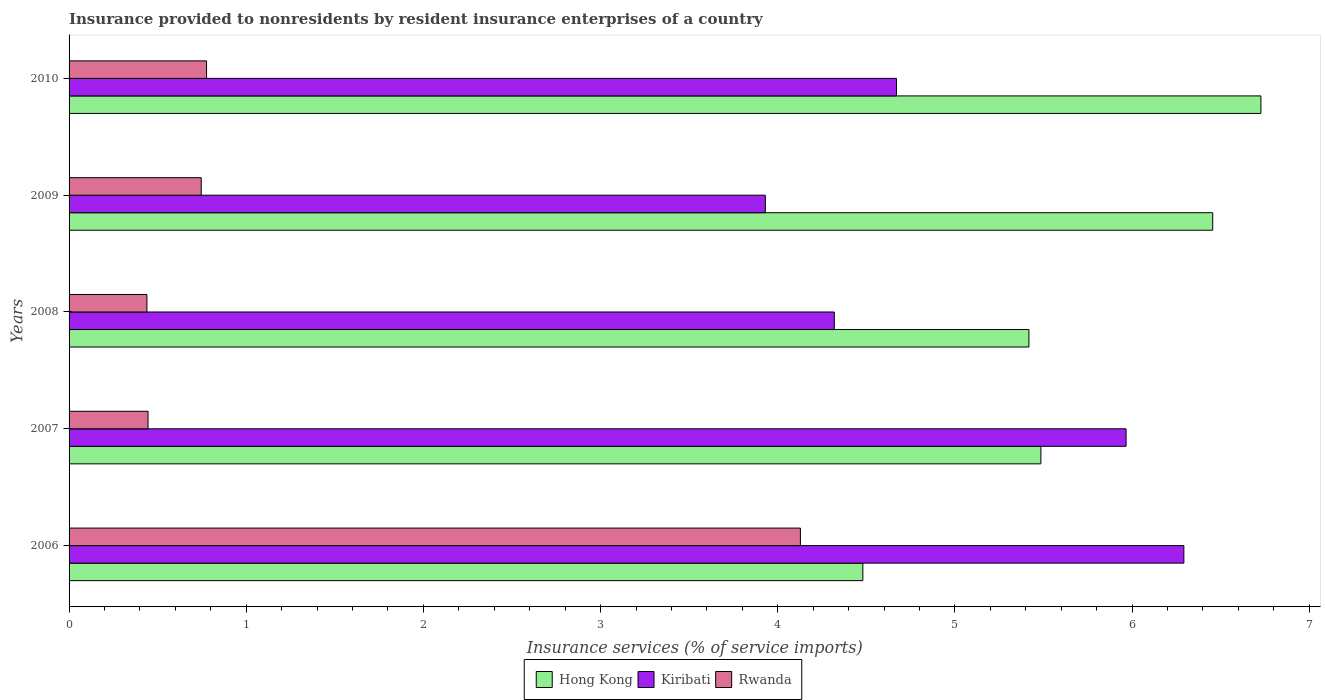How many different coloured bars are there?
Offer a terse response. 3. Are the number of bars per tick equal to the number of legend labels?
Your response must be concise. Yes. How many bars are there on the 5th tick from the bottom?
Keep it short and to the point. 3. What is the insurance provided to nonresidents in Kiribati in 2007?
Ensure brevity in your answer.  5.97. Across all years, what is the maximum insurance provided to nonresidents in Kiribati?
Your answer should be very brief. 6.29. Across all years, what is the minimum insurance provided to nonresidents in Hong Kong?
Keep it short and to the point. 4.48. What is the total insurance provided to nonresidents in Rwanda in the graph?
Make the answer very short. 6.53. What is the difference between the insurance provided to nonresidents in Rwanda in 2006 and that in 2007?
Your answer should be very brief. 3.68. What is the difference between the insurance provided to nonresidents in Kiribati in 2009 and the insurance provided to nonresidents in Rwanda in 2007?
Provide a short and direct response. 3.48. What is the average insurance provided to nonresidents in Kiribati per year?
Your answer should be very brief. 5.04. In the year 2008, what is the difference between the insurance provided to nonresidents in Rwanda and insurance provided to nonresidents in Kiribati?
Make the answer very short. -3.88. In how many years, is the insurance provided to nonresidents in Rwanda greater than 2 %?
Make the answer very short. 1. What is the ratio of the insurance provided to nonresidents in Rwanda in 2007 to that in 2008?
Ensure brevity in your answer.  1.01. What is the difference between the highest and the second highest insurance provided to nonresidents in Hong Kong?
Ensure brevity in your answer.  0.27. What is the difference between the highest and the lowest insurance provided to nonresidents in Hong Kong?
Keep it short and to the point. 2.25. What does the 3rd bar from the top in 2009 represents?
Offer a terse response. Hong Kong. What does the 1st bar from the bottom in 2008 represents?
Your answer should be very brief. Hong Kong. How many bars are there?
Your response must be concise. 15. Are all the bars in the graph horizontal?
Provide a short and direct response. Yes. How many years are there in the graph?
Your answer should be compact. 5. Does the graph contain any zero values?
Ensure brevity in your answer.  No. Does the graph contain grids?
Your answer should be compact. No. Where does the legend appear in the graph?
Provide a short and direct response. Bottom center. What is the title of the graph?
Your answer should be compact. Insurance provided to nonresidents by resident insurance enterprises of a country. Does "High income: nonOECD" appear as one of the legend labels in the graph?
Offer a terse response. No. What is the label or title of the X-axis?
Your answer should be very brief. Insurance services (% of service imports). What is the Insurance services (% of service imports) in Hong Kong in 2006?
Your response must be concise. 4.48. What is the Insurance services (% of service imports) in Kiribati in 2006?
Your response must be concise. 6.29. What is the Insurance services (% of service imports) in Rwanda in 2006?
Provide a succinct answer. 4.13. What is the Insurance services (% of service imports) in Hong Kong in 2007?
Offer a very short reply. 5.49. What is the Insurance services (% of service imports) of Kiribati in 2007?
Offer a very short reply. 5.97. What is the Insurance services (% of service imports) in Rwanda in 2007?
Your response must be concise. 0.45. What is the Insurance services (% of service imports) of Hong Kong in 2008?
Provide a short and direct response. 5.42. What is the Insurance services (% of service imports) in Kiribati in 2008?
Offer a terse response. 4.32. What is the Insurance services (% of service imports) of Rwanda in 2008?
Your response must be concise. 0.44. What is the Insurance services (% of service imports) in Hong Kong in 2009?
Make the answer very short. 6.45. What is the Insurance services (% of service imports) in Kiribati in 2009?
Make the answer very short. 3.93. What is the Insurance services (% of service imports) in Rwanda in 2009?
Your response must be concise. 0.75. What is the Insurance services (% of service imports) in Hong Kong in 2010?
Your response must be concise. 6.73. What is the Insurance services (% of service imports) in Kiribati in 2010?
Your response must be concise. 4.67. What is the Insurance services (% of service imports) in Rwanda in 2010?
Keep it short and to the point. 0.78. Across all years, what is the maximum Insurance services (% of service imports) of Hong Kong?
Your answer should be compact. 6.73. Across all years, what is the maximum Insurance services (% of service imports) in Kiribati?
Give a very brief answer. 6.29. Across all years, what is the maximum Insurance services (% of service imports) in Rwanda?
Give a very brief answer. 4.13. Across all years, what is the minimum Insurance services (% of service imports) in Hong Kong?
Your response must be concise. 4.48. Across all years, what is the minimum Insurance services (% of service imports) in Kiribati?
Give a very brief answer. 3.93. Across all years, what is the minimum Insurance services (% of service imports) in Rwanda?
Ensure brevity in your answer.  0.44. What is the total Insurance services (% of service imports) in Hong Kong in the graph?
Keep it short and to the point. 28.56. What is the total Insurance services (% of service imports) of Kiribati in the graph?
Your answer should be very brief. 25.18. What is the total Insurance services (% of service imports) in Rwanda in the graph?
Keep it short and to the point. 6.53. What is the difference between the Insurance services (% of service imports) in Hong Kong in 2006 and that in 2007?
Your answer should be compact. -1. What is the difference between the Insurance services (% of service imports) of Kiribati in 2006 and that in 2007?
Your answer should be very brief. 0.33. What is the difference between the Insurance services (% of service imports) in Rwanda in 2006 and that in 2007?
Your answer should be very brief. 3.68. What is the difference between the Insurance services (% of service imports) of Hong Kong in 2006 and that in 2008?
Ensure brevity in your answer.  -0.94. What is the difference between the Insurance services (% of service imports) of Kiribati in 2006 and that in 2008?
Give a very brief answer. 1.97. What is the difference between the Insurance services (% of service imports) of Rwanda in 2006 and that in 2008?
Give a very brief answer. 3.69. What is the difference between the Insurance services (% of service imports) of Hong Kong in 2006 and that in 2009?
Make the answer very short. -1.97. What is the difference between the Insurance services (% of service imports) in Kiribati in 2006 and that in 2009?
Provide a short and direct response. 2.36. What is the difference between the Insurance services (% of service imports) in Rwanda in 2006 and that in 2009?
Ensure brevity in your answer.  3.38. What is the difference between the Insurance services (% of service imports) in Hong Kong in 2006 and that in 2010?
Provide a succinct answer. -2.25. What is the difference between the Insurance services (% of service imports) of Kiribati in 2006 and that in 2010?
Provide a short and direct response. 1.62. What is the difference between the Insurance services (% of service imports) of Rwanda in 2006 and that in 2010?
Your answer should be compact. 3.35. What is the difference between the Insurance services (% of service imports) of Hong Kong in 2007 and that in 2008?
Provide a short and direct response. 0.07. What is the difference between the Insurance services (% of service imports) of Kiribati in 2007 and that in 2008?
Your answer should be very brief. 1.65. What is the difference between the Insurance services (% of service imports) of Rwanda in 2007 and that in 2008?
Your response must be concise. 0.01. What is the difference between the Insurance services (% of service imports) in Hong Kong in 2007 and that in 2009?
Keep it short and to the point. -0.97. What is the difference between the Insurance services (% of service imports) in Kiribati in 2007 and that in 2009?
Your answer should be very brief. 2.04. What is the difference between the Insurance services (% of service imports) of Rwanda in 2007 and that in 2009?
Ensure brevity in your answer.  -0.3. What is the difference between the Insurance services (% of service imports) in Hong Kong in 2007 and that in 2010?
Give a very brief answer. -1.24. What is the difference between the Insurance services (% of service imports) in Kiribati in 2007 and that in 2010?
Keep it short and to the point. 1.3. What is the difference between the Insurance services (% of service imports) of Rwanda in 2007 and that in 2010?
Make the answer very short. -0.33. What is the difference between the Insurance services (% of service imports) in Hong Kong in 2008 and that in 2009?
Offer a very short reply. -1.04. What is the difference between the Insurance services (% of service imports) in Kiribati in 2008 and that in 2009?
Your answer should be compact. 0.39. What is the difference between the Insurance services (% of service imports) in Rwanda in 2008 and that in 2009?
Make the answer very short. -0.31. What is the difference between the Insurance services (% of service imports) of Hong Kong in 2008 and that in 2010?
Your answer should be compact. -1.31. What is the difference between the Insurance services (% of service imports) of Kiribati in 2008 and that in 2010?
Your answer should be compact. -0.35. What is the difference between the Insurance services (% of service imports) of Rwanda in 2008 and that in 2010?
Keep it short and to the point. -0.34. What is the difference between the Insurance services (% of service imports) in Hong Kong in 2009 and that in 2010?
Your response must be concise. -0.27. What is the difference between the Insurance services (% of service imports) of Kiribati in 2009 and that in 2010?
Your answer should be compact. -0.74. What is the difference between the Insurance services (% of service imports) in Rwanda in 2009 and that in 2010?
Give a very brief answer. -0.03. What is the difference between the Insurance services (% of service imports) of Hong Kong in 2006 and the Insurance services (% of service imports) of Kiribati in 2007?
Provide a succinct answer. -1.49. What is the difference between the Insurance services (% of service imports) in Hong Kong in 2006 and the Insurance services (% of service imports) in Rwanda in 2007?
Give a very brief answer. 4.03. What is the difference between the Insurance services (% of service imports) in Kiribati in 2006 and the Insurance services (% of service imports) in Rwanda in 2007?
Offer a terse response. 5.85. What is the difference between the Insurance services (% of service imports) of Hong Kong in 2006 and the Insurance services (% of service imports) of Kiribati in 2008?
Your answer should be very brief. 0.16. What is the difference between the Insurance services (% of service imports) in Hong Kong in 2006 and the Insurance services (% of service imports) in Rwanda in 2008?
Your answer should be very brief. 4.04. What is the difference between the Insurance services (% of service imports) of Kiribati in 2006 and the Insurance services (% of service imports) of Rwanda in 2008?
Your answer should be very brief. 5.85. What is the difference between the Insurance services (% of service imports) in Hong Kong in 2006 and the Insurance services (% of service imports) in Kiribati in 2009?
Your answer should be compact. 0.55. What is the difference between the Insurance services (% of service imports) of Hong Kong in 2006 and the Insurance services (% of service imports) of Rwanda in 2009?
Make the answer very short. 3.73. What is the difference between the Insurance services (% of service imports) of Kiribati in 2006 and the Insurance services (% of service imports) of Rwanda in 2009?
Offer a terse response. 5.55. What is the difference between the Insurance services (% of service imports) of Hong Kong in 2006 and the Insurance services (% of service imports) of Kiribati in 2010?
Ensure brevity in your answer.  -0.19. What is the difference between the Insurance services (% of service imports) in Hong Kong in 2006 and the Insurance services (% of service imports) in Rwanda in 2010?
Offer a very short reply. 3.7. What is the difference between the Insurance services (% of service imports) in Kiribati in 2006 and the Insurance services (% of service imports) in Rwanda in 2010?
Make the answer very short. 5.52. What is the difference between the Insurance services (% of service imports) in Hong Kong in 2007 and the Insurance services (% of service imports) in Kiribati in 2008?
Keep it short and to the point. 1.17. What is the difference between the Insurance services (% of service imports) in Hong Kong in 2007 and the Insurance services (% of service imports) in Rwanda in 2008?
Make the answer very short. 5.05. What is the difference between the Insurance services (% of service imports) in Kiribati in 2007 and the Insurance services (% of service imports) in Rwanda in 2008?
Keep it short and to the point. 5.53. What is the difference between the Insurance services (% of service imports) in Hong Kong in 2007 and the Insurance services (% of service imports) in Kiribati in 2009?
Provide a short and direct response. 1.56. What is the difference between the Insurance services (% of service imports) in Hong Kong in 2007 and the Insurance services (% of service imports) in Rwanda in 2009?
Offer a very short reply. 4.74. What is the difference between the Insurance services (% of service imports) of Kiribati in 2007 and the Insurance services (% of service imports) of Rwanda in 2009?
Keep it short and to the point. 5.22. What is the difference between the Insurance services (% of service imports) in Hong Kong in 2007 and the Insurance services (% of service imports) in Kiribati in 2010?
Ensure brevity in your answer.  0.81. What is the difference between the Insurance services (% of service imports) in Hong Kong in 2007 and the Insurance services (% of service imports) in Rwanda in 2010?
Provide a succinct answer. 4.71. What is the difference between the Insurance services (% of service imports) in Kiribati in 2007 and the Insurance services (% of service imports) in Rwanda in 2010?
Provide a short and direct response. 5.19. What is the difference between the Insurance services (% of service imports) in Hong Kong in 2008 and the Insurance services (% of service imports) in Kiribati in 2009?
Ensure brevity in your answer.  1.49. What is the difference between the Insurance services (% of service imports) in Hong Kong in 2008 and the Insurance services (% of service imports) in Rwanda in 2009?
Ensure brevity in your answer.  4.67. What is the difference between the Insurance services (% of service imports) of Kiribati in 2008 and the Insurance services (% of service imports) of Rwanda in 2009?
Provide a succinct answer. 3.57. What is the difference between the Insurance services (% of service imports) of Hong Kong in 2008 and the Insurance services (% of service imports) of Kiribati in 2010?
Your answer should be compact. 0.75. What is the difference between the Insurance services (% of service imports) in Hong Kong in 2008 and the Insurance services (% of service imports) in Rwanda in 2010?
Offer a terse response. 4.64. What is the difference between the Insurance services (% of service imports) in Kiribati in 2008 and the Insurance services (% of service imports) in Rwanda in 2010?
Ensure brevity in your answer.  3.54. What is the difference between the Insurance services (% of service imports) in Hong Kong in 2009 and the Insurance services (% of service imports) in Kiribati in 2010?
Your answer should be compact. 1.78. What is the difference between the Insurance services (% of service imports) of Hong Kong in 2009 and the Insurance services (% of service imports) of Rwanda in 2010?
Provide a short and direct response. 5.68. What is the difference between the Insurance services (% of service imports) in Kiribati in 2009 and the Insurance services (% of service imports) in Rwanda in 2010?
Your response must be concise. 3.15. What is the average Insurance services (% of service imports) in Hong Kong per year?
Your response must be concise. 5.71. What is the average Insurance services (% of service imports) of Kiribati per year?
Make the answer very short. 5.04. What is the average Insurance services (% of service imports) in Rwanda per year?
Offer a terse response. 1.31. In the year 2006, what is the difference between the Insurance services (% of service imports) of Hong Kong and Insurance services (% of service imports) of Kiribati?
Your answer should be compact. -1.81. In the year 2006, what is the difference between the Insurance services (% of service imports) in Hong Kong and Insurance services (% of service imports) in Rwanda?
Keep it short and to the point. 0.35. In the year 2006, what is the difference between the Insurance services (% of service imports) of Kiribati and Insurance services (% of service imports) of Rwanda?
Provide a short and direct response. 2.16. In the year 2007, what is the difference between the Insurance services (% of service imports) in Hong Kong and Insurance services (% of service imports) in Kiribati?
Your response must be concise. -0.48. In the year 2007, what is the difference between the Insurance services (% of service imports) in Hong Kong and Insurance services (% of service imports) in Rwanda?
Keep it short and to the point. 5.04. In the year 2007, what is the difference between the Insurance services (% of service imports) in Kiribati and Insurance services (% of service imports) in Rwanda?
Your answer should be compact. 5.52. In the year 2008, what is the difference between the Insurance services (% of service imports) in Hong Kong and Insurance services (% of service imports) in Kiribati?
Offer a terse response. 1.1. In the year 2008, what is the difference between the Insurance services (% of service imports) in Hong Kong and Insurance services (% of service imports) in Rwanda?
Give a very brief answer. 4.98. In the year 2008, what is the difference between the Insurance services (% of service imports) in Kiribati and Insurance services (% of service imports) in Rwanda?
Keep it short and to the point. 3.88. In the year 2009, what is the difference between the Insurance services (% of service imports) of Hong Kong and Insurance services (% of service imports) of Kiribati?
Your response must be concise. 2.52. In the year 2009, what is the difference between the Insurance services (% of service imports) in Hong Kong and Insurance services (% of service imports) in Rwanda?
Ensure brevity in your answer.  5.71. In the year 2009, what is the difference between the Insurance services (% of service imports) of Kiribati and Insurance services (% of service imports) of Rwanda?
Your answer should be very brief. 3.18. In the year 2010, what is the difference between the Insurance services (% of service imports) of Hong Kong and Insurance services (% of service imports) of Kiribati?
Keep it short and to the point. 2.06. In the year 2010, what is the difference between the Insurance services (% of service imports) in Hong Kong and Insurance services (% of service imports) in Rwanda?
Make the answer very short. 5.95. In the year 2010, what is the difference between the Insurance services (% of service imports) of Kiribati and Insurance services (% of service imports) of Rwanda?
Offer a very short reply. 3.89. What is the ratio of the Insurance services (% of service imports) of Hong Kong in 2006 to that in 2007?
Offer a terse response. 0.82. What is the ratio of the Insurance services (% of service imports) in Kiribati in 2006 to that in 2007?
Offer a very short reply. 1.05. What is the ratio of the Insurance services (% of service imports) of Rwanda in 2006 to that in 2007?
Provide a succinct answer. 9.26. What is the ratio of the Insurance services (% of service imports) of Hong Kong in 2006 to that in 2008?
Ensure brevity in your answer.  0.83. What is the ratio of the Insurance services (% of service imports) of Kiribati in 2006 to that in 2008?
Your answer should be very brief. 1.46. What is the ratio of the Insurance services (% of service imports) of Rwanda in 2006 to that in 2008?
Keep it short and to the point. 9.4. What is the ratio of the Insurance services (% of service imports) of Hong Kong in 2006 to that in 2009?
Provide a succinct answer. 0.69. What is the ratio of the Insurance services (% of service imports) in Kiribati in 2006 to that in 2009?
Make the answer very short. 1.6. What is the ratio of the Insurance services (% of service imports) of Rwanda in 2006 to that in 2009?
Give a very brief answer. 5.53. What is the ratio of the Insurance services (% of service imports) of Hong Kong in 2006 to that in 2010?
Make the answer very short. 0.67. What is the ratio of the Insurance services (% of service imports) of Kiribati in 2006 to that in 2010?
Your answer should be very brief. 1.35. What is the ratio of the Insurance services (% of service imports) in Rwanda in 2006 to that in 2010?
Your answer should be very brief. 5.32. What is the ratio of the Insurance services (% of service imports) of Hong Kong in 2007 to that in 2008?
Provide a short and direct response. 1.01. What is the ratio of the Insurance services (% of service imports) in Kiribati in 2007 to that in 2008?
Your response must be concise. 1.38. What is the ratio of the Insurance services (% of service imports) in Rwanda in 2007 to that in 2008?
Provide a succinct answer. 1.01. What is the ratio of the Insurance services (% of service imports) of Hong Kong in 2007 to that in 2009?
Your answer should be very brief. 0.85. What is the ratio of the Insurance services (% of service imports) in Kiribati in 2007 to that in 2009?
Your answer should be very brief. 1.52. What is the ratio of the Insurance services (% of service imports) of Rwanda in 2007 to that in 2009?
Your answer should be very brief. 0.6. What is the ratio of the Insurance services (% of service imports) in Hong Kong in 2007 to that in 2010?
Your answer should be very brief. 0.82. What is the ratio of the Insurance services (% of service imports) of Kiribati in 2007 to that in 2010?
Give a very brief answer. 1.28. What is the ratio of the Insurance services (% of service imports) in Rwanda in 2007 to that in 2010?
Provide a short and direct response. 0.57. What is the ratio of the Insurance services (% of service imports) in Hong Kong in 2008 to that in 2009?
Your response must be concise. 0.84. What is the ratio of the Insurance services (% of service imports) of Kiribati in 2008 to that in 2009?
Your response must be concise. 1.1. What is the ratio of the Insurance services (% of service imports) in Rwanda in 2008 to that in 2009?
Make the answer very short. 0.59. What is the ratio of the Insurance services (% of service imports) of Hong Kong in 2008 to that in 2010?
Offer a terse response. 0.81. What is the ratio of the Insurance services (% of service imports) in Kiribati in 2008 to that in 2010?
Make the answer very short. 0.92. What is the ratio of the Insurance services (% of service imports) of Rwanda in 2008 to that in 2010?
Keep it short and to the point. 0.57. What is the ratio of the Insurance services (% of service imports) in Hong Kong in 2009 to that in 2010?
Your answer should be compact. 0.96. What is the ratio of the Insurance services (% of service imports) of Kiribati in 2009 to that in 2010?
Your answer should be very brief. 0.84. What is the ratio of the Insurance services (% of service imports) in Rwanda in 2009 to that in 2010?
Provide a succinct answer. 0.96. What is the difference between the highest and the second highest Insurance services (% of service imports) in Hong Kong?
Your answer should be compact. 0.27. What is the difference between the highest and the second highest Insurance services (% of service imports) of Kiribati?
Provide a short and direct response. 0.33. What is the difference between the highest and the second highest Insurance services (% of service imports) in Rwanda?
Offer a terse response. 3.35. What is the difference between the highest and the lowest Insurance services (% of service imports) in Hong Kong?
Your response must be concise. 2.25. What is the difference between the highest and the lowest Insurance services (% of service imports) of Kiribati?
Provide a short and direct response. 2.36. What is the difference between the highest and the lowest Insurance services (% of service imports) in Rwanda?
Give a very brief answer. 3.69. 